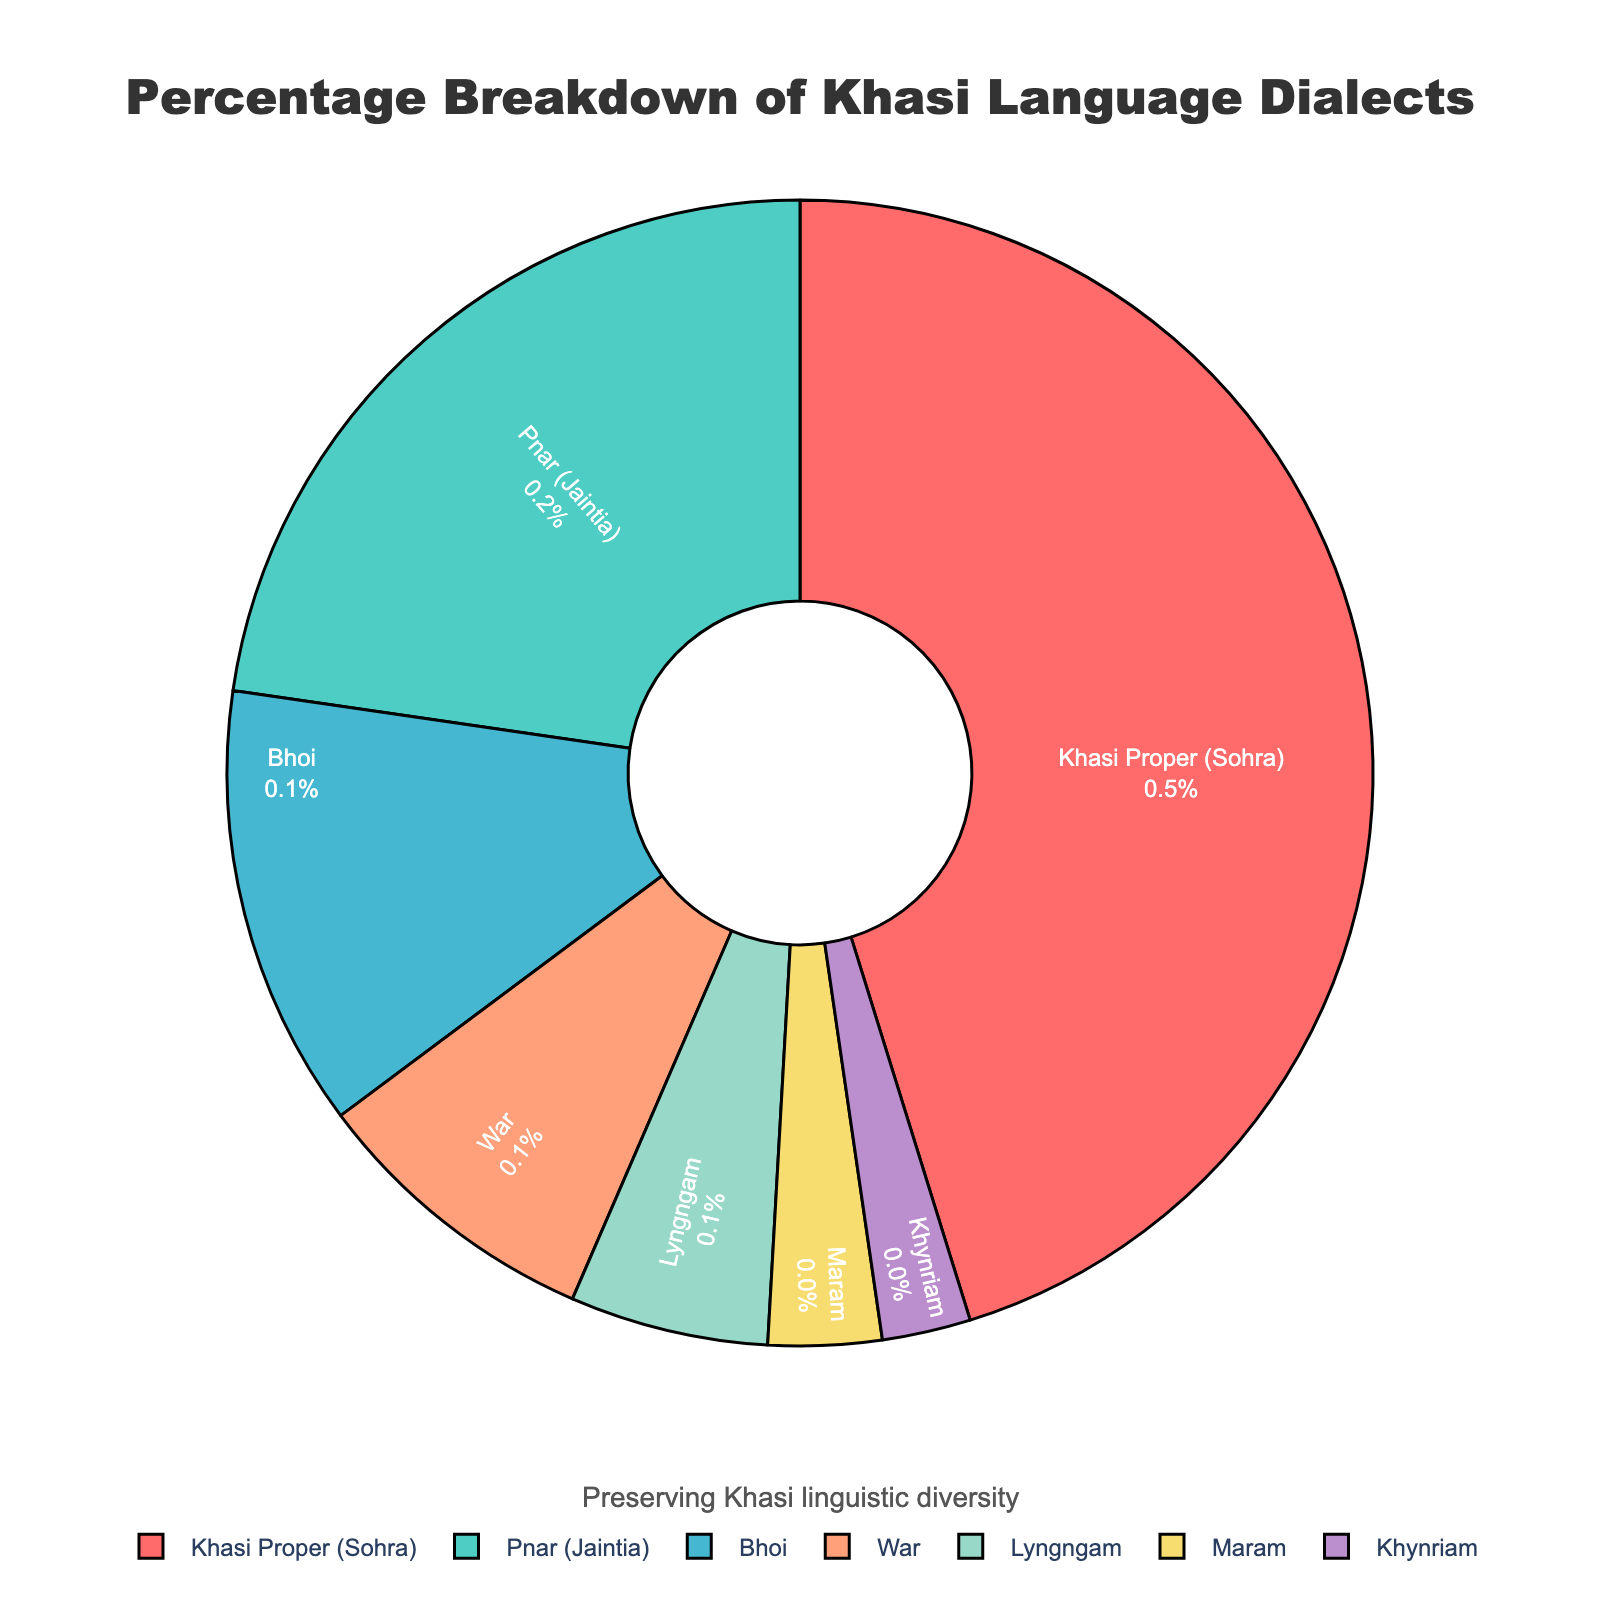Which dialect has the highest percentage? The highest percentage section is of Khasi Proper (Sohra), which is visually the largest segment of the pie chart.
Answer: Khasi Proper (Sohra) Which dialects make up more than half of the total percentage? Summing the percentages of Khasi Proper (45.2%) and Pnar (22.7%) exceeds 50% (45.2 + 22.7 = 67.9%), which visually occupies more than half of the pie chart.
Answer: Khasi Proper (Sohra) and Pnar (Jaintia) How does the percentage of Bhoi compare to that of War? The pie chart shows Bhoi at 12.5% and War at 8.3%. By comparing these values, Bhoi is greater.
Answer: Bhoi is greater than War What is the combined percentage of the least three spoken dialects? Adding the percentages of Maram (3.2%), Khynriam (2.5%), and Lyngngam (5.6%) gives a total of 11.3%.
Answer: 11.3% What is the difference in percentage between the most and least common dialects? The most common is Khasi Proper (45.2%) and the least common is Khynriam (2.5%). Subtracting these values (45.2 - 2.5) gives the difference.
Answer: 42.7% What color represents the Pnar dialect? The Pnar dialect segment is marked by a distinct green shade, easily identifiable in the pie chart among other colors.
Answer: Green How many dialects have a percentage greater than 10%? Examining the pie chart shows Khasi Proper (45.2%), Pnar (22.7%), and Bhoi (12.5%) all have percentages above 10%.
Answer: Three Is the combined percentage of Lyngngam and Maram more or less than that of Bhoi? Adding Lyngngam’s 5.6% and Maram’s 3.2% results in 8.8%, which is less than Bhoi’s 12.5%.
Answer: Less Which two dialects have the closest percentages? The percentages of Lyngngam (5.6%) and Maram (3.2%) are the closest, compared to other pairs.
Answer: Lyngngam and Maram 